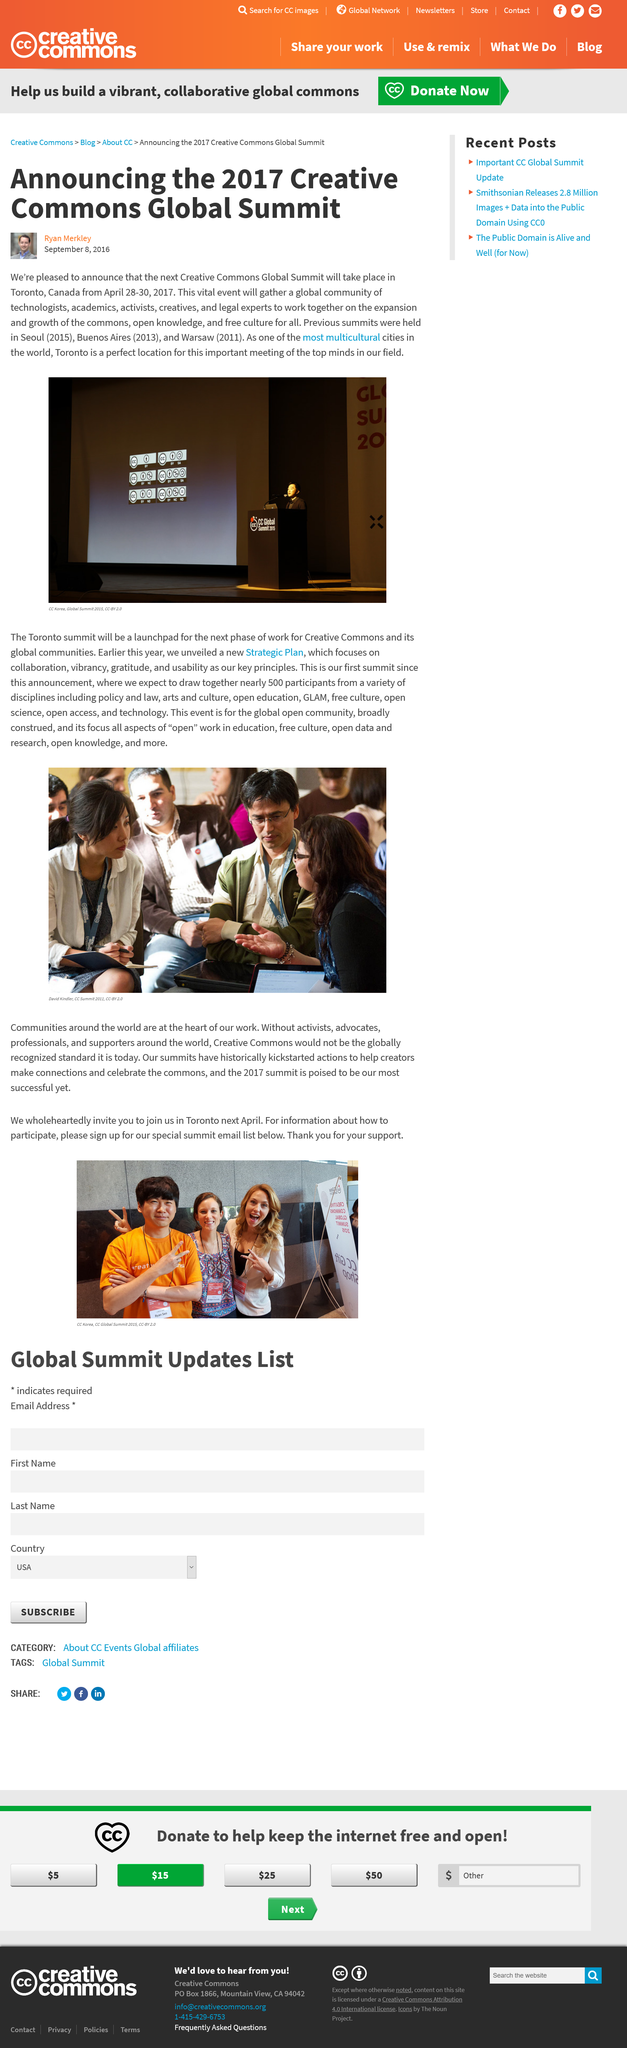Highlight a few significant elements in this photo. The Creative Commons Global Summit will take place in Toronto. Ryan Merkley published the article "Announcing the 2017 Creative Commons Global Summit" on September 8th, 2016. The 2013 summit was held in Buenos Aires. 